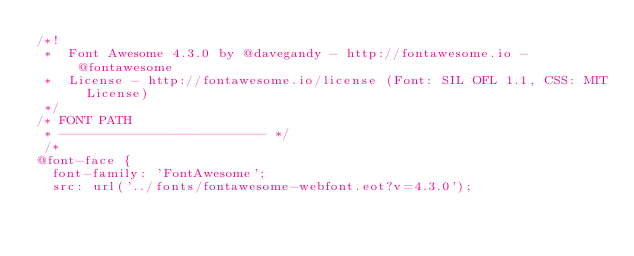Convert code to text. <code><loc_0><loc_0><loc_500><loc_500><_CSS_>/*!
 *  Font Awesome 4.3.0 by @davegandy - http://fontawesome.io - @fontawesome
 *  License - http://fontawesome.io/license (Font: SIL OFL 1.1, CSS: MIT License)
 */
/* FONT PATH
 * -------------------------- */
 /*
@font-face {
  font-family: 'FontAwesome';
  src: url('../fonts/fontawesome-webfont.eot?v=4.3.0');</code> 